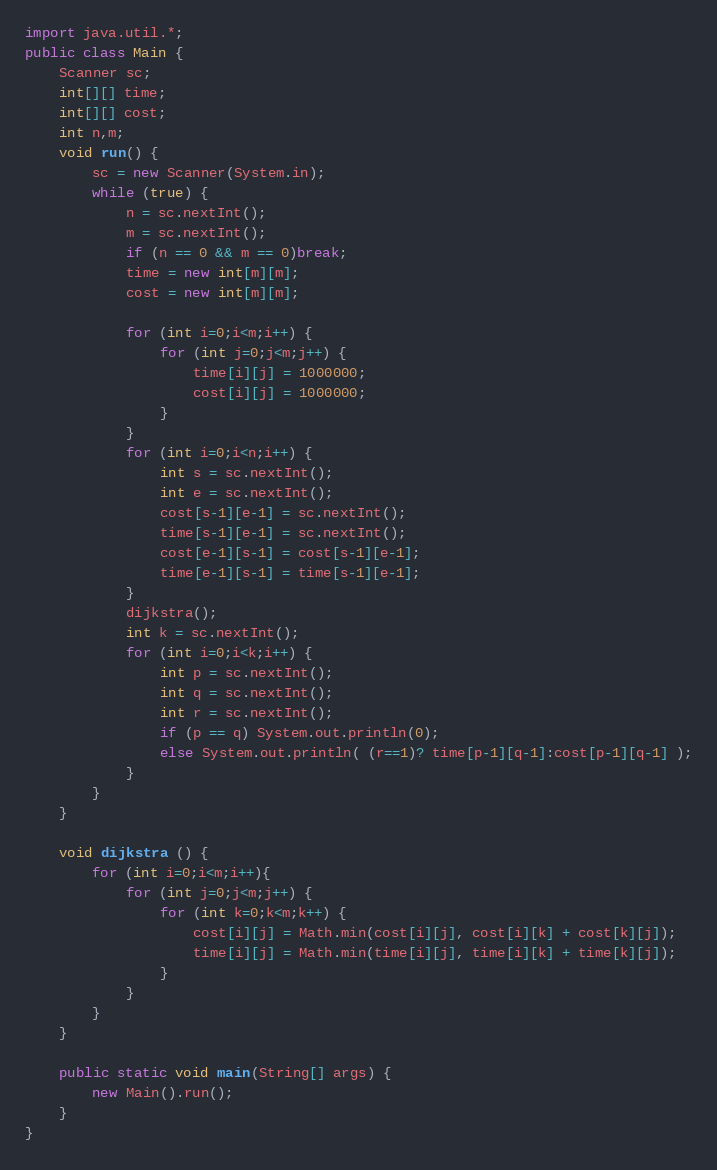<code> <loc_0><loc_0><loc_500><loc_500><_Java_>import java.util.*;
public class Main {
	Scanner sc;
	int[][] time;
	int[][] cost;
	int n,m;
	void run() {
		sc = new Scanner(System.in);
		while (true) {
			n = sc.nextInt();
			m = sc.nextInt();
			if (n == 0 && m == 0)break;
			time = new int[m][m];
			cost = new int[m][m];
			
			for (int i=0;i<m;i++) {
				for (int j=0;j<m;j++) {
					time[i][j] = 1000000;
					cost[i][j] = 1000000;
				}
			}
			for (int i=0;i<n;i++) {
				int s = sc.nextInt();
				int e = sc.nextInt();
				cost[s-1][e-1] = sc.nextInt();
				time[s-1][e-1] = sc.nextInt();
				cost[e-1][s-1] = cost[s-1][e-1];
				time[e-1][s-1] = time[s-1][e-1];
	 		}
			dijkstra();
			int k = sc.nextInt();
			for (int i=0;i<k;i++) {
				int p = sc.nextInt();
				int q = sc.nextInt();
				int r = sc.nextInt();
				if (p == q) System.out.println(0);
				else System.out.println( (r==1)? time[p-1][q-1]:cost[p-1][q-1] );
			}
		}
	}
	
	void dijkstra () {
		for (int i=0;i<m;i++){
			for (int j=0;j<m;j++) {
				for (int k=0;k<m;k++) {
					cost[i][j] = Math.min(cost[i][j], cost[i][k] + cost[k][j]);
					time[i][j] = Math.min(time[i][j], time[i][k] + time[k][j]);
				}
			}
		}
	}
	
	public static void main(String[] args) {
		new Main().run();
	}
}</code> 